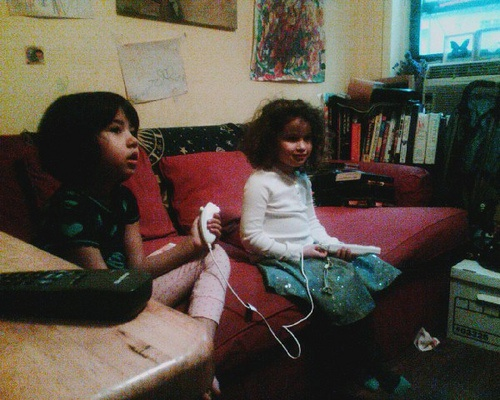Describe the objects in this image and their specific colors. I can see couch in darkgray, black, maroon, and brown tones, people in darkgray, black, maroon, and gray tones, people in darkgray, black, teal, and lightgray tones, dining table in darkgray, tan, gray, and black tones, and remote in darkgray, black, gray, teal, and darkgreen tones in this image. 